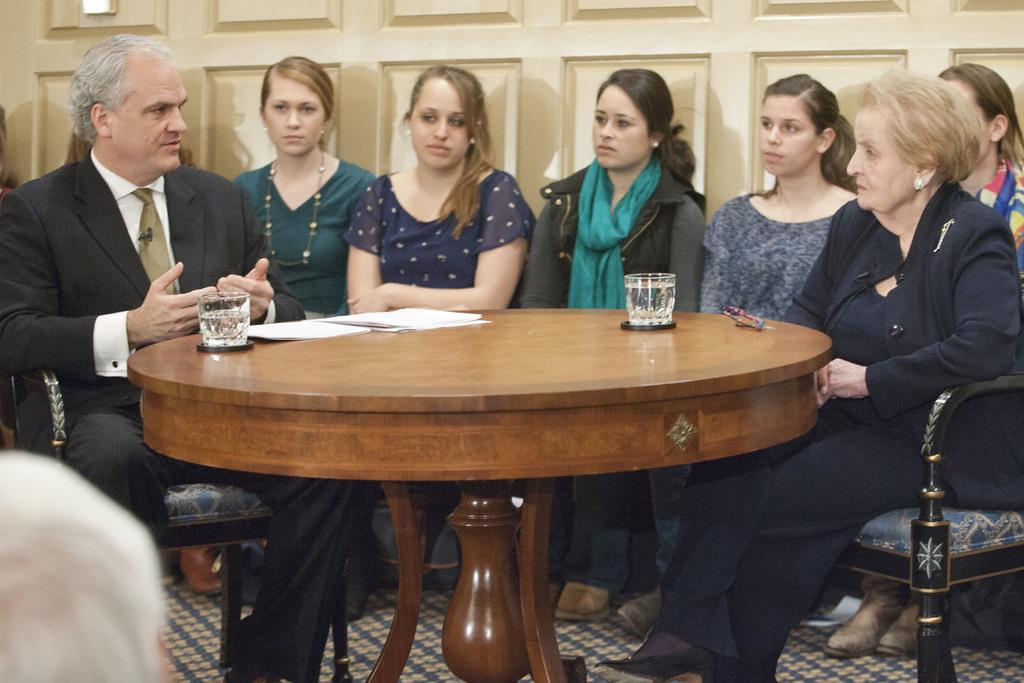Who is present in the image? There is a man and a woman in the image. What are they doing in the image? The man and the woman are sitting in chairs and discussing with each other. Where are they sitting? They are sitting at a table. What can be seen on the table? There are papers and two water glasses on the table. What type of owl can be seen sitting on the man's shoulder in the image? There is no owl present in the image; it only features a man and a woman sitting at a table and discussing with each other. 